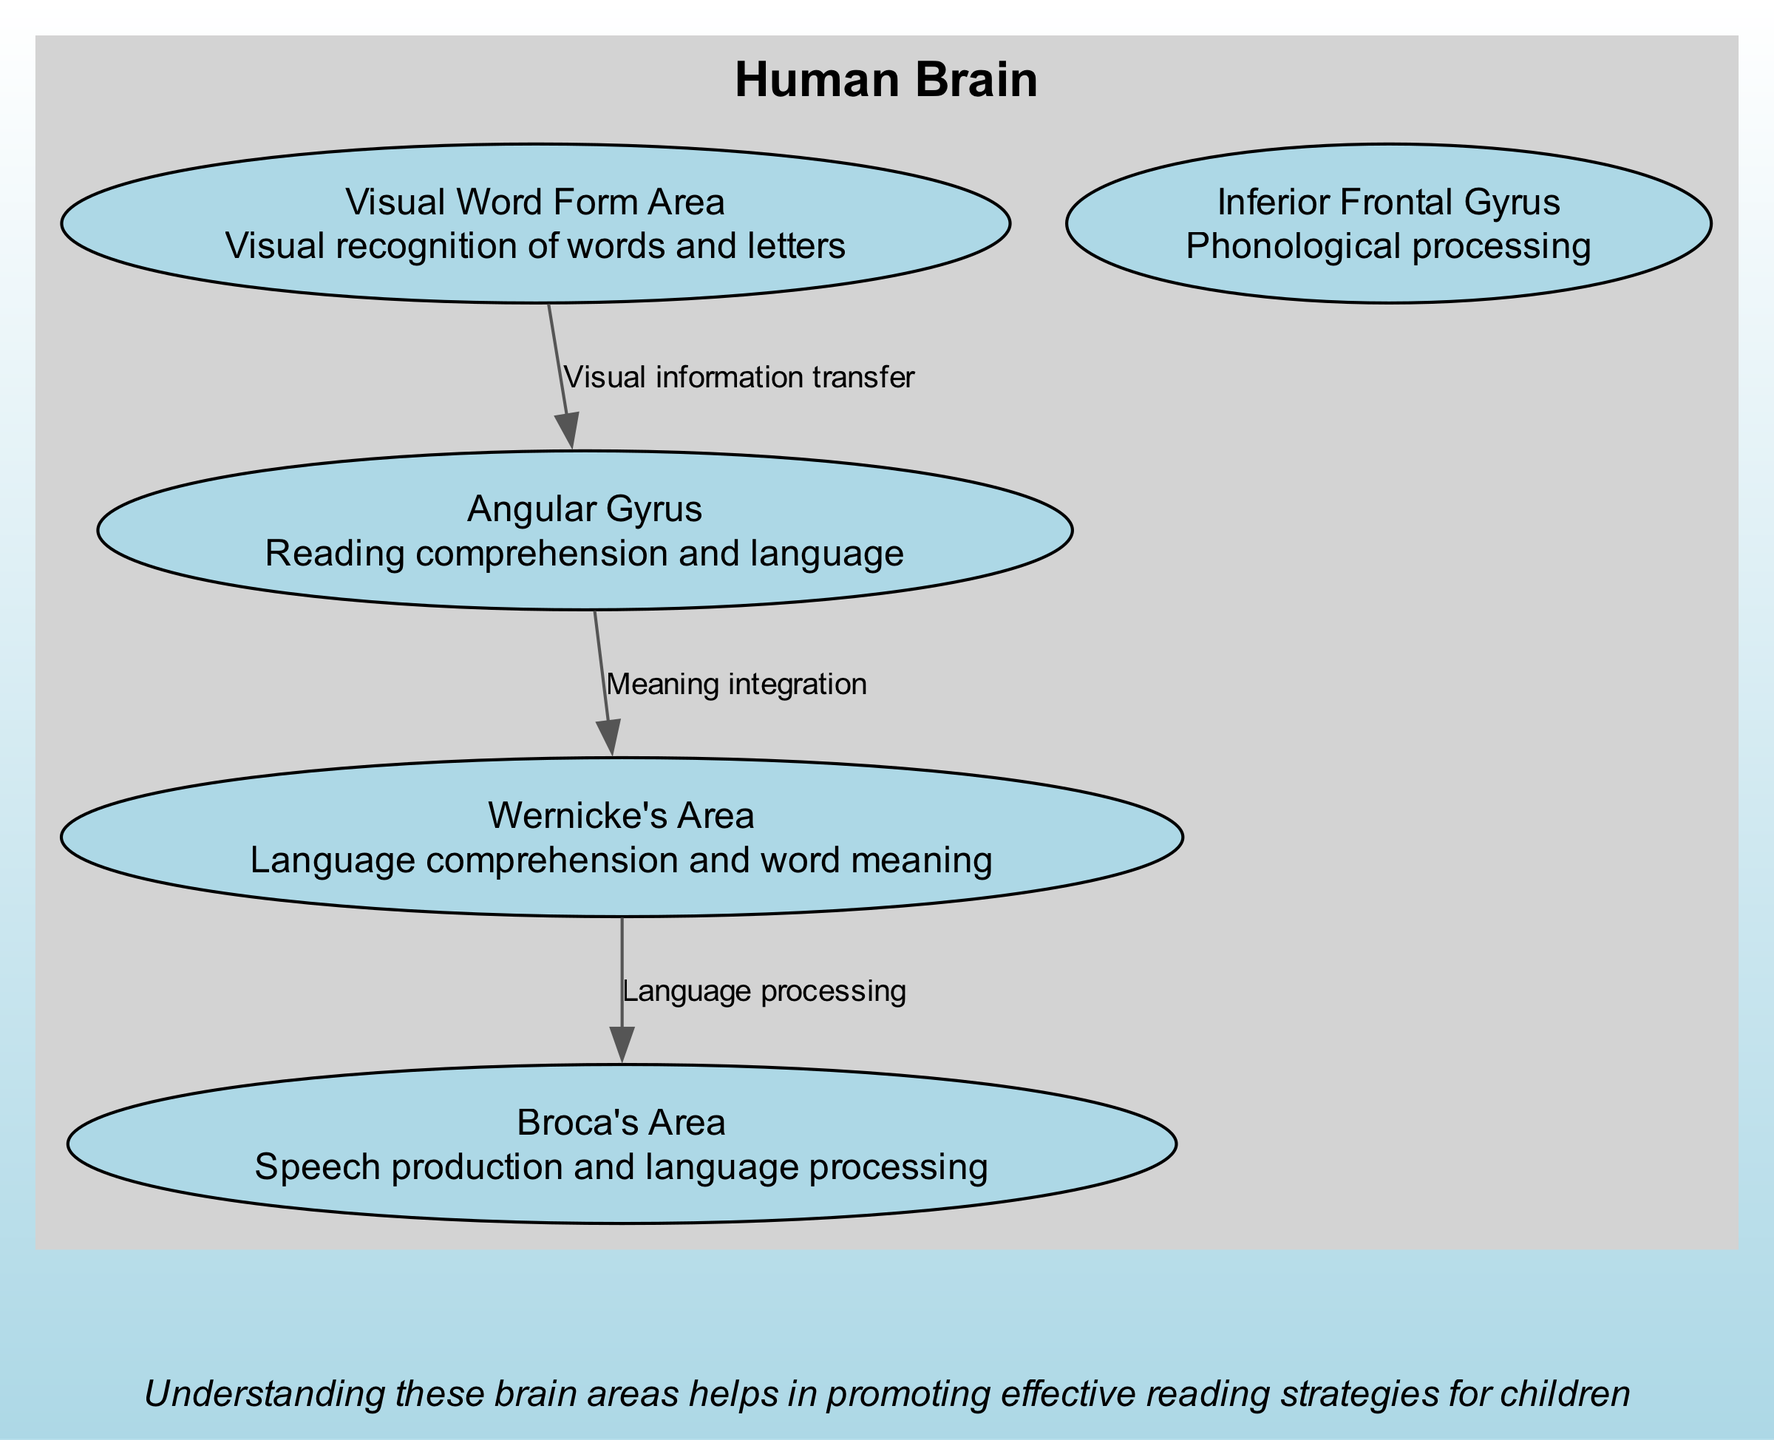What is the function of Broca's Area? Broca's Area is labeled in the diagram with its function stated as "Speech production and language processing".
Answer: Speech production and language processing Which area is responsible for language comprehension? The diagram indicates that Wernicke's Area handles "Language comprehension and word meaning," as highlighted in the depicted areas.
Answer: Wernicke's Area How many highlighted areas are related to language and reading in the diagram? The diagram displays five distinct highlighted areas associated with language and reading skills, which are clearly outlined in the list of highlighted areas.
Answer: 5 What area connects Visual Word Form Area to Angular Gyrus? The connections show that the relationship between Visual Word Form Area and Angular Gyrus is marked as "Visual information transfer". This indicates a direct flow of information between these two areas.
Answer: Visual information transfer Which area integrates meaning and connects to Wernicke's Area? The Angular Gyrus is specified in the connections as integrating meaning and linking directly to Wernicke's Area, confirming its role in this process.
Answer: Angular Gyrus What does the Visual Word Form Area specifically recognize? The function of the Visual Word Form Area is described as related to "Visual recognition of words and letters", which is explicitly stated in the highlighted areas.
Answer: Visual recognition of words and letters What is the direction of the connection from Wernicke's Area to Broca's Area? The connection routes from Wernicke's Area to Broca's Area, indicated by the labeling of "Language processing", meaning that information flows from comprehension to production.
Answer: Language processing What function does the Inferior Frontal Gyrus serve? The Inferior Frontal Gyrus is mentioned for its role in "Phonological processing", referencing its specific function related to language skills in the diagram.
Answer: Phonological processing 